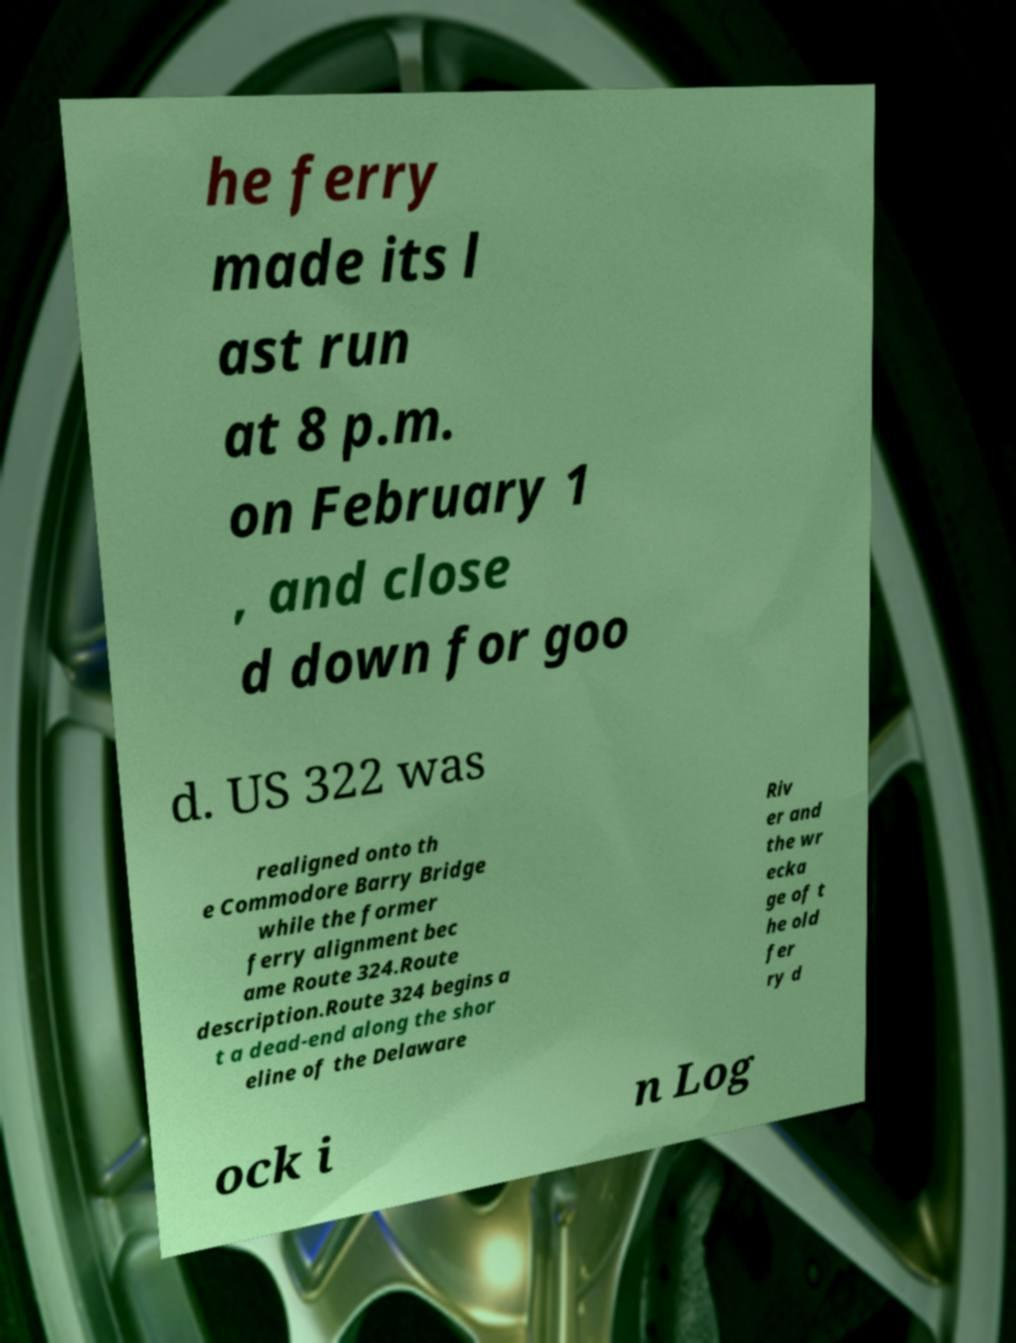Can you accurately transcribe the text from the provided image for me? he ferry made its l ast run at 8 p.m. on February 1 , and close d down for goo d. US 322 was realigned onto th e Commodore Barry Bridge while the former ferry alignment bec ame Route 324.Route description.Route 324 begins a t a dead-end along the shor eline of the Delaware Riv er and the wr ecka ge of t he old fer ry d ock i n Log 